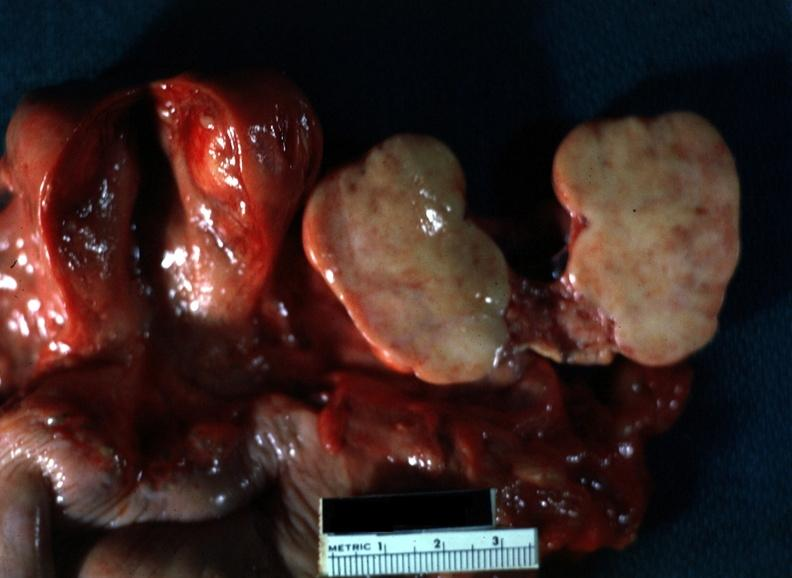s ovary present?
Answer the question using a single word or phrase. Yes 